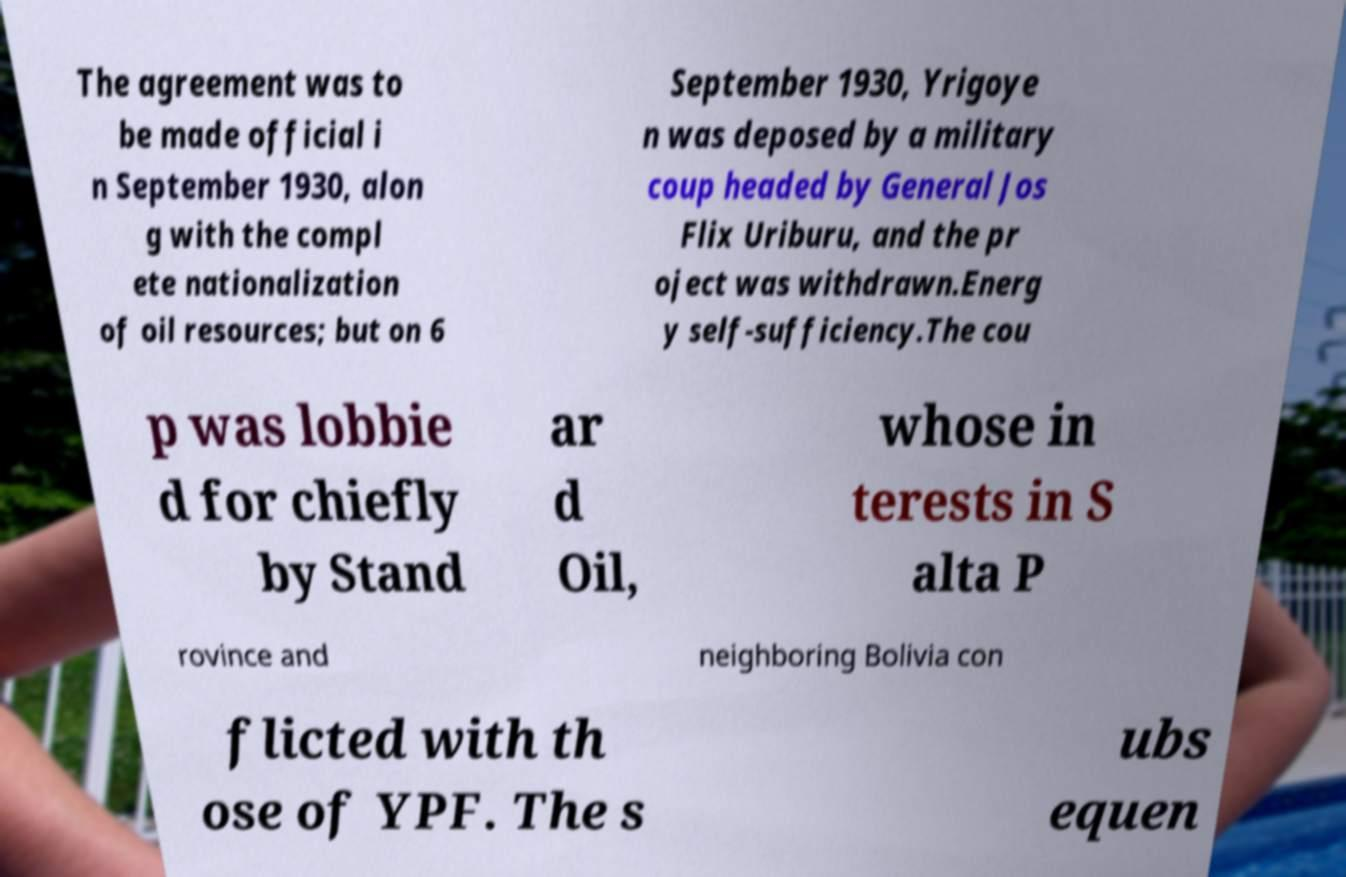I need the written content from this picture converted into text. Can you do that? The agreement was to be made official i n September 1930, alon g with the compl ete nationalization of oil resources; but on 6 September 1930, Yrigoye n was deposed by a military coup headed by General Jos Flix Uriburu, and the pr oject was withdrawn.Energ y self-sufficiency.The cou p was lobbie d for chiefly by Stand ar d Oil, whose in terests in S alta P rovince and neighboring Bolivia con flicted with th ose of YPF. The s ubs equen 